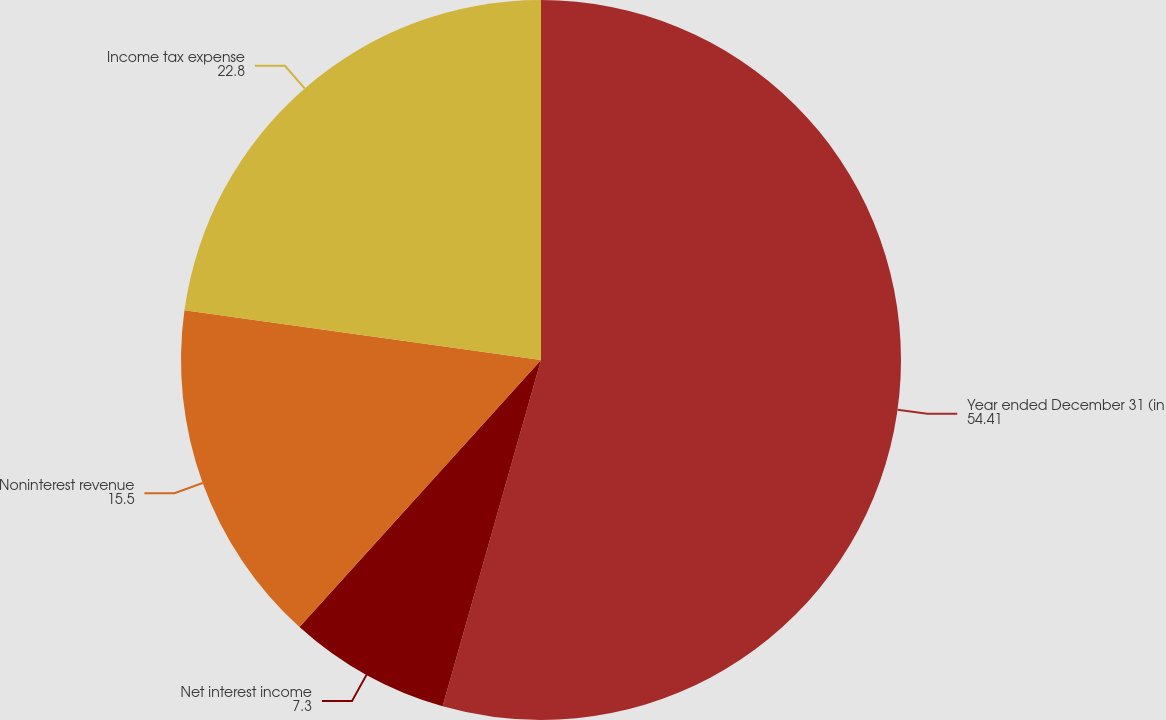<chart> <loc_0><loc_0><loc_500><loc_500><pie_chart><fcel>Year ended December 31 (in<fcel>Net interest income<fcel>Noninterest revenue<fcel>Income tax expense<nl><fcel>54.41%<fcel>7.3%<fcel>15.5%<fcel>22.8%<nl></chart> 